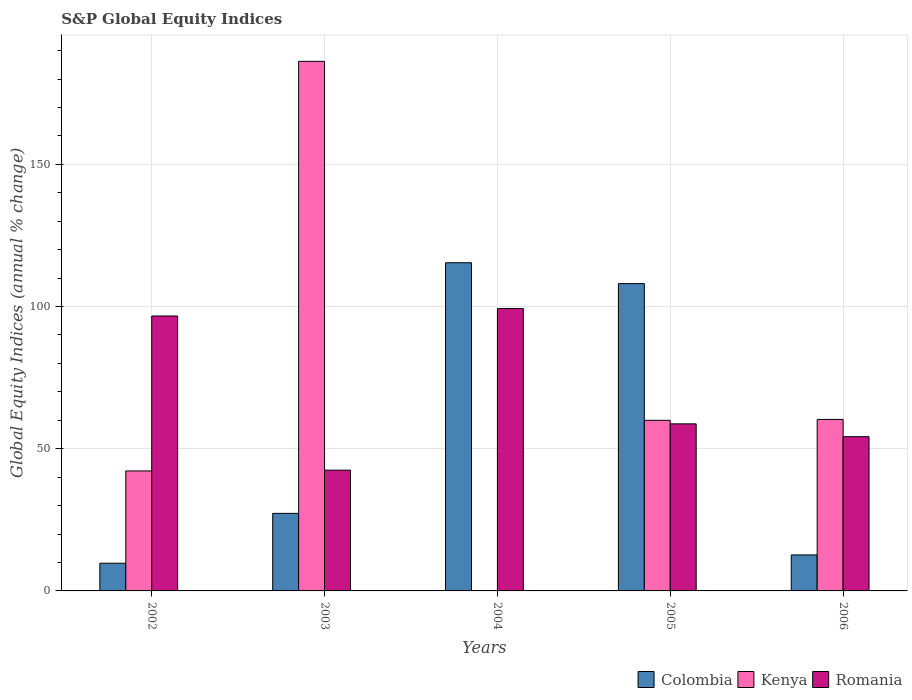How many different coloured bars are there?
Your answer should be compact. 3. Are the number of bars on each tick of the X-axis equal?
Ensure brevity in your answer.  No. What is the label of the 4th group of bars from the left?
Your response must be concise. 2005. What is the global equity indices in Colombia in 2005?
Your response must be concise. 108.06. Across all years, what is the maximum global equity indices in Romania?
Make the answer very short. 99.3. Across all years, what is the minimum global equity indices in Romania?
Your answer should be very brief. 42.46. What is the total global equity indices in Romania in the graph?
Your answer should be very brief. 351.41. What is the difference between the global equity indices in Romania in 2002 and that in 2005?
Your response must be concise. 37.93. What is the difference between the global equity indices in Romania in 2005 and the global equity indices in Colombia in 2004?
Provide a succinct answer. -56.65. What is the average global equity indices in Colombia per year?
Provide a succinct answer. 54.62. In the year 2003, what is the difference between the global equity indices in Kenya and global equity indices in Romania?
Keep it short and to the point. 143.75. What is the ratio of the global equity indices in Romania in 2005 to that in 2006?
Offer a terse response. 1.08. Is the global equity indices in Colombia in 2002 less than that in 2006?
Provide a succinct answer. Yes. Is the difference between the global equity indices in Kenya in 2003 and 2006 greater than the difference between the global equity indices in Romania in 2003 and 2006?
Your answer should be compact. Yes. What is the difference between the highest and the second highest global equity indices in Kenya?
Make the answer very short. 125.91. What is the difference between the highest and the lowest global equity indices in Romania?
Keep it short and to the point. 56.84. In how many years, is the global equity indices in Kenya greater than the average global equity indices in Kenya taken over all years?
Your answer should be compact. 1. Is the sum of the global equity indices in Kenya in 2003 and 2005 greater than the maximum global equity indices in Colombia across all years?
Your answer should be compact. Yes. Are all the bars in the graph horizontal?
Your answer should be very brief. No. How many years are there in the graph?
Keep it short and to the point. 5. Does the graph contain any zero values?
Your answer should be compact. Yes. Does the graph contain grids?
Your response must be concise. Yes. How are the legend labels stacked?
Ensure brevity in your answer.  Horizontal. What is the title of the graph?
Give a very brief answer. S&P Global Equity Indices. What is the label or title of the Y-axis?
Your answer should be very brief. Global Equity Indices (annual % change). What is the Global Equity Indices (annual % change) of Colombia in 2002?
Keep it short and to the point. 9.73. What is the Global Equity Indices (annual % change) of Kenya in 2002?
Keep it short and to the point. 42.19. What is the Global Equity Indices (annual % change) of Romania in 2002?
Make the answer very short. 96.67. What is the Global Equity Indices (annual % change) in Colombia in 2003?
Your answer should be compact. 27.27. What is the Global Equity Indices (annual % change) in Kenya in 2003?
Offer a very short reply. 186.21. What is the Global Equity Indices (annual % change) in Romania in 2003?
Your answer should be very brief. 42.46. What is the Global Equity Indices (annual % change) of Colombia in 2004?
Provide a succinct answer. 115.39. What is the Global Equity Indices (annual % change) in Romania in 2004?
Your response must be concise. 99.3. What is the Global Equity Indices (annual % change) of Colombia in 2005?
Keep it short and to the point. 108.06. What is the Global Equity Indices (annual % change) in Kenya in 2005?
Provide a succinct answer. 59.99. What is the Global Equity Indices (annual % change) of Romania in 2005?
Ensure brevity in your answer.  58.74. What is the Global Equity Indices (annual % change) in Colombia in 2006?
Keep it short and to the point. 12.66. What is the Global Equity Indices (annual % change) of Kenya in 2006?
Provide a succinct answer. 60.3. What is the Global Equity Indices (annual % change) of Romania in 2006?
Give a very brief answer. 54.23. Across all years, what is the maximum Global Equity Indices (annual % change) of Colombia?
Your answer should be very brief. 115.39. Across all years, what is the maximum Global Equity Indices (annual % change) of Kenya?
Offer a terse response. 186.21. Across all years, what is the maximum Global Equity Indices (annual % change) of Romania?
Your answer should be very brief. 99.3. Across all years, what is the minimum Global Equity Indices (annual % change) of Colombia?
Your answer should be compact. 9.73. Across all years, what is the minimum Global Equity Indices (annual % change) of Romania?
Offer a very short reply. 42.46. What is the total Global Equity Indices (annual % change) in Colombia in the graph?
Offer a very short reply. 273.1. What is the total Global Equity Indices (annual % change) of Kenya in the graph?
Offer a terse response. 348.69. What is the total Global Equity Indices (annual % change) of Romania in the graph?
Provide a short and direct response. 351.41. What is the difference between the Global Equity Indices (annual % change) in Colombia in 2002 and that in 2003?
Provide a short and direct response. -17.54. What is the difference between the Global Equity Indices (annual % change) of Kenya in 2002 and that in 2003?
Offer a very short reply. -144.02. What is the difference between the Global Equity Indices (annual % change) of Romania in 2002 and that in 2003?
Your answer should be compact. 54.21. What is the difference between the Global Equity Indices (annual % change) in Colombia in 2002 and that in 2004?
Ensure brevity in your answer.  -105.66. What is the difference between the Global Equity Indices (annual % change) of Romania in 2002 and that in 2004?
Provide a succinct answer. -2.63. What is the difference between the Global Equity Indices (annual % change) of Colombia in 2002 and that in 2005?
Offer a terse response. -98.33. What is the difference between the Global Equity Indices (annual % change) of Kenya in 2002 and that in 2005?
Your answer should be very brief. -17.8. What is the difference between the Global Equity Indices (annual % change) of Romania in 2002 and that in 2005?
Your answer should be very brief. 37.93. What is the difference between the Global Equity Indices (annual % change) of Colombia in 2002 and that in 2006?
Provide a succinct answer. -2.93. What is the difference between the Global Equity Indices (annual % change) of Kenya in 2002 and that in 2006?
Offer a very short reply. -18.11. What is the difference between the Global Equity Indices (annual % change) in Romania in 2002 and that in 2006?
Your response must be concise. 42.44. What is the difference between the Global Equity Indices (annual % change) of Colombia in 2003 and that in 2004?
Ensure brevity in your answer.  -88.12. What is the difference between the Global Equity Indices (annual % change) of Romania in 2003 and that in 2004?
Your answer should be very brief. -56.84. What is the difference between the Global Equity Indices (annual % change) of Colombia in 2003 and that in 2005?
Offer a very short reply. -80.79. What is the difference between the Global Equity Indices (annual % change) of Kenya in 2003 and that in 2005?
Give a very brief answer. 126.22. What is the difference between the Global Equity Indices (annual % change) in Romania in 2003 and that in 2005?
Provide a succinct answer. -16.28. What is the difference between the Global Equity Indices (annual % change) of Colombia in 2003 and that in 2006?
Give a very brief answer. 14.61. What is the difference between the Global Equity Indices (annual % change) in Kenya in 2003 and that in 2006?
Provide a succinct answer. 125.91. What is the difference between the Global Equity Indices (annual % change) in Romania in 2003 and that in 2006?
Your answer should be compact. -11.77. What is the difference between the Global Equity Indices (annual % change) of Colombia in 2004 and that in 2005?
Ensure brevity in your answer.  7.33. What is the difference between the Global Equity Indices (annual % change) in Romania in 2004 and that in 2005?
Provide a succinct answer. 40.56. What is the difference between the Global Equity Indices (annual % change) in Colombia in 2004 and that in 2006?
Offer a very short reply. 102.73. What is the difference between the Global Equity Indices (annual % change) in Romania in 2004 and that in 2006?
Your answer should be compact. 45.07. What is the difference between the Global Equity Indices (annual % change) of Colombia in 2005 and that in 2006?
Provide a short and direct response. 95.4. What is the difference between the Global Equity Indices (annual % change) in Kenya in 2005 and that in 2006?
Provide a short and direct response. -0.32. What is the difference between the Global Equity Indices (annual % change) of Romania in 2005 and that in 2006?
Give a very brief answer. 4.51. What is the difference between the Global Equity Indices (annual % change) in Colombia in 2002 and the Global Equity Indices (annual % change) in Kenya in 2003?
Provide a short and direct response. -176.48. What is the difference between the Global Equity Indices (annual % change) of Colombia in 2002 and the Global Equity Indices (annual % change) of Romania in 2003?
Provide a short and direct response. -32.73. What is the difference between the Global Equity Indices (annual % change) in Kenya in 2002 and the Global Equity Indices (annual % change) in Romania in 2003?
Your answer should be compact. -0.27. What is the difference between the Global Equity Indices (annual % change) of Colombia in 2002 and the Global Equity Indices (annual % change) of Romania in 2004?
Your response must be concise. -89.57. What is the difference between the Global Equity Indices (annual % change) of Kenya in 2002 and the Global Equity Indices (annual % change) of Romania in 2004?
Give a very brief answer. -57.11. What is the difference between the Global Equity Indices (annual % change) of Colombia in 2002 and the Global Equity Indices (annual % change) of Kenya in 2005?
Provide a short and direct response. -50.26. What is the difference between the Global Equity Indices (annual % change) of Colombia in 2002 and the Global Equity Indices (annual % change) of Romania in 2005?
Offer a very short reply. -49.01. What is the difference between the Global Equity Indices (annual % change) in Kenya in 2002 and the Global Equity Indices (annual % change) in Romania in 2005?
Give a very brief answer. -16.55. What is the difference between the Global Equity Indices (annual % change) in Colombia in 2002 and the Global Equity Indices (annual % change) in Kenya in 2006?
Ensure brevity in your answer.  -50.57. What is the difference between the Global Equity Indices (annual % change) in Colombia in 2002 and the Global Equity Indices (annual % change) in Romania in 2006?
Provide a short and direct response. -44.5. What is the difference between the Global Equity Indices (annual % change) of Kenya in 2002 and the Global Equity Indices (annual % change) of Romania in 2006?
Provide a short and direct response. -12.04. What is the difference between the Global Equity Indices (annual % change) in Colombia in 2003 and the Global Equity Indices (annual % change) in Romania in 2004?
Give a very brief answer. -72.03. What is the difference between the Global Equity Indices (annual % change) of Kenya in 2003 and the Global Equity Indices (annual % change) of Romania in 2004?
Give a very brief answer. 86.91. What is the difference between the Global Equity Indices (annual % change) in Colombia in 2003 and the Global Equity Indices (annual % change) in Kenya in 2005?
Ensure brevity in your answer.  -32.72. What is the difference between the Global Equity Indices (annual % change) of Colombia in 2003 and the Global Equity Indices (annual % change) of Romania in 2005?
Keep it short and to the point. -31.47. What is the difference between the Global Equity Indices (annual % change) of Kenya in 2003 and the Global Equity Indices (annual % change) of Romania in 2005?
Keep it short and to the point. 127.47. What is the difference between the Global Equity Indices (annual % change) of Colombia in 2003 and the Global Equity Indices (annual % change) of Kenya in 2006?
Provide a succinct answer. -33.03. What is the difference between the Global Equity Indices (annual % change) in Colombia in 2003 and the Global Equity Indices (annual % change) in Romania in 2006?
Offer a terse response. -26.96. What is the difference between the Global Equity Indices (annual % change) of Kenya in 2003 and the Global Equity Indices (annual % change) of Romania in 2006?
Provide a short and direct response. 131.98. What is the difference between the Global Equity Indices (annual % change) of Colombia in 2004 and the Global Equity Indices (annual % change) of Kenya in 2005?
Provide a short and direct response. 55.4. What is the difference between the Global Equity Indices (annual % change) in Colombia in 2004 and the Global Equity Indices (annual % change) in Romania in 2005?
Offer a terse response. 56.65. What is the difference between the Global Equity Indices (annual % change) of Colombia in 2004 and the Global Equity Indices (annual % change) of Kenya in 2006?
Offer a terse response. 55.09. What is the difference between the Global Equity Indices (annual % change) in Colombia in 2004 and the Global Equity Indices (annual % change) in Romania in 2006?
Your response must be concise. 61.16. What is the difference between the Global Equity Indices (annual % change) in Colombia in 2005 and the Global Equity Indices (annual % change) in Kenya in 2006?
Your response must be concise. 47.75. What is the difference between the Global Equity Indices (annual % change) of Colombia in 2005 and the Global Equity Indices (annual % change) of Romania in 2006?
Provide a short and direct response. 53.82. What is the difference between the Global Equity Indices (annual % change) in Kenya in 2005 and the Global Equity Indices (annual % change) in Romania in 2006?
Offer a very short reply. 5.75. What is the average Global Equity Indices (annual % change) in Colombia per year?
Your response must be concise. 54.62. What is the average Global Equity Indices (annual % change) in Kenya per year?
Keep it short and to the point. 69.74. What is the average Global Equity Indices (annual % change) of Romania per year?
Keep it short and to the point. 70.28. In the year 2002, what is the difference between the Global Equity Indices (annual % change) of Colombia and Global Equity Indices (annual % change) of Kenya?
Your answer should be compact. -32.46. In the year 2002, what is the difference between the Global Equity Indices (annual % change) in Colombia and Global Equity Indices (annual % change) in Romania?
Provide a short and direct response. -86.94. In the year 2002, what is the difference between the Global Equity Indices (annual % change) of Kenya and Global Equity Indices (annual % change) of Romania?
Offer a terse response. -54.48. In the year 2003, what is the difference between the Global Equity Indices (annual % change) of Colombia and Global Equity Indices (annual % change) of Kenya?
Keep it short and to the point. -158.94. In the year 2003, what is the difference between the Global Equity Indices (annual % change) in Colombia and Global Equity Indices (annual % change) in Romania?
Your answer should be very brief. -15.19. In the year 2003, what is the difference between the Global Equity Indices (annual % change) in Kenya and Global Equity Indices (annual % change) in Romania?
Give a very brief answer. 143.75. In the year 2004, what is the difference between the Global Equity Indices (annual % change) in Colombia and Global Equity Indices (annual % change) in Romania?
Make the answer very short. 16.09. In the year 2005, what is the difference between the Global Equity Indices (annual % change) of Colombia and Global Equity Indices (annual % change) of Kenya?
Ensure brevity in your answer.  48.07. In the year 2005, what is the difference between the Global Equity Indices (annual % change) in Colombia and Global Equity Indices (annual % change) in Romania?
Your answer should be very brief. 49.31. In the year 2005, what is the difference between the Global Equity Indices (annual % change) of Kenya and Global Equity Indices (annual % change) of Romania?
Give a very brief answer. 1.24. In the year 2006, what is the difference between the Global Equity Indices (annual % change) of Colombia and Global Equity Indices (annual % change) of Kenya?
Offer a very short reply. -47.64. In the year 2006, what is the difference between the Global Equity Indices (annual % change) in Colombia and Global Equity Indices (annual % change) in Romania?
Your response must be concise. -41.58. In the year 2006, what is the difference between the Global Equity Indices (annual % change) of Kenya and Global Equity Indices (annual % change) of Romania?
Offer a very short reply. 6.07. What is the ratio of the Global Equity Indices (annual % change) in Colombia in 2002 to that in 2003?
Make the answer very short. 0.36. What is the ratio of the Global Equity Indices (annual % change) of Kenya in 2002 to that in 2003?
Ensure brevity in your answer.  0.23. What is the ratio of the Global Equity Indices (annual % change) of Romania in 2002 to that in 2003?
Your answer should be very brief. 2.28. What is the ratio of the Global Equity Indices (annual % change) in Colombia in 2002 to that in 2004?
Offer a very short reply. 0.08. What is the ratio of the Global Equity Indices (annual % change) in Romania in 2002 to that in 2004?
Offer a terse response. 0.97. What is the ratio of the Global Equity Indices (annual % change) in Colombia in 2002 to that in 2005?
Offer a very short reply. 0.09. What is the ratio of the Global Equity Indices (annual % change) in Kenya in 2002 to that in 2005?
Offer a very short reply. 0.7. What is the ratio of the Global Equity Indices (annual % change) of Romania in 2002 to that in 2005?
Offer a terse response. 1.65. What is the ratio of the Global Equity Indices (annual % change) in Colombia in 2002 to that in 2006?
Offer a terse response. 0.77. What is the ratio of the Global Equity Indices (annual % change) of Kenya in 2002 to that in 2006?
Give a very brief answer. 0.7. What is the ratio of the Global Equity Indices (annual % change) of Romania in 2002 to that in 2006?
Your response must be concise. 1.78. What is the ratio of the Global Equity Indices (annual % change) of Colombia in 2003 to that in 2004?
Keep it short and to the point. 0.24. What is the ratio of the Global Equity Indices (annual % change) of Romania in 2003 to that in 2004?
Give a very brief answer. 0.43. What is the ratio of the Global Equity Indices (annual % change) of Colombia in 2003 to that in 2005?
Give a very brief answer. 0.25. What is the ratio of the Global Equity Indices (annual % change) in Kenya in 2003 to that in 2005?
Give a very brief answer. 3.1. What is the ratio of the Global Equity Indices (annual % change) of Romania in 2003 to that in 2005?
Ensure brevity in your answer.  0.72. What is the ratio of the Global Equity Indices (annual % change) in Colombia in 2003 to that in 2006?
Your answer should be compact. 2.15. What is the ratio of the Global Equity Indices (annual % change) in Kenya in 2003 to that in 2006?
Ensure brevity in your answer.  3.09. What is the ratio of the Global Equity Indices (annual % change) in Romania in 2003 to that in 2006?
Your answer should be compact. 0.78. What is the ratio of the Global Equity Indices (annual % change) of Colombia in 2004 to that in 2005?
Provide a short and direct response. 1.07. What is the ratio of the Global Equity Indices (annual % change) of Romania in 2004 to that in 2005?
Offer a very short reply. 1.69. What is the ratio of the Global Equity Indices (annual % change) in Colombia in 2004 to that in 2006?
Offer a very short reply. 9.12. What is the ratio of the Global Equity Indices (annual % change) of Romania in 2004 to that in 2006?
Ensure brevity in your answer.  1.83. What is the ratio of the Global Equity Indices (annual % change) in Colombia in 2005 to that in 2006?
Make the answer very short. 8.54. What is the ratio of the Global Equity Indices (annual % change) of Kenya in 2005 to that in 2006?
Make the answer very short. 0.99. What is the ratio of the Global Equity Indices (annual % change) of Romania in 2005 to that in 2006?
Your answer should be compact. 1.08. What is the difference between the highest and the second highest Global Equity Indices (annual % change) of Colombia?
Offer a very short reply. 7.33. What is the difference between the highest and the second highest Global Equity Indices (annual % change) in Kenya?
Provide a succinct answer. 125.91. What is the difference between the highest and the second highest Global Equity Indices (annual % change) in Romania?
Offer a terse response. 2.63. What is the difference between the highest and the lowest Global Equity Indices (annual % change) in Colombia?
Offer a very short reply. 105.66. What is the difference between the highest and the lowest Global Equity Indices (annual % change) in Kenya?
Your answer should be compact. 186.21. What is the difference between the highest and the lowest Global Equity Indices (annual % change) in Romania?
Provide a succinct answer. 56.84. 